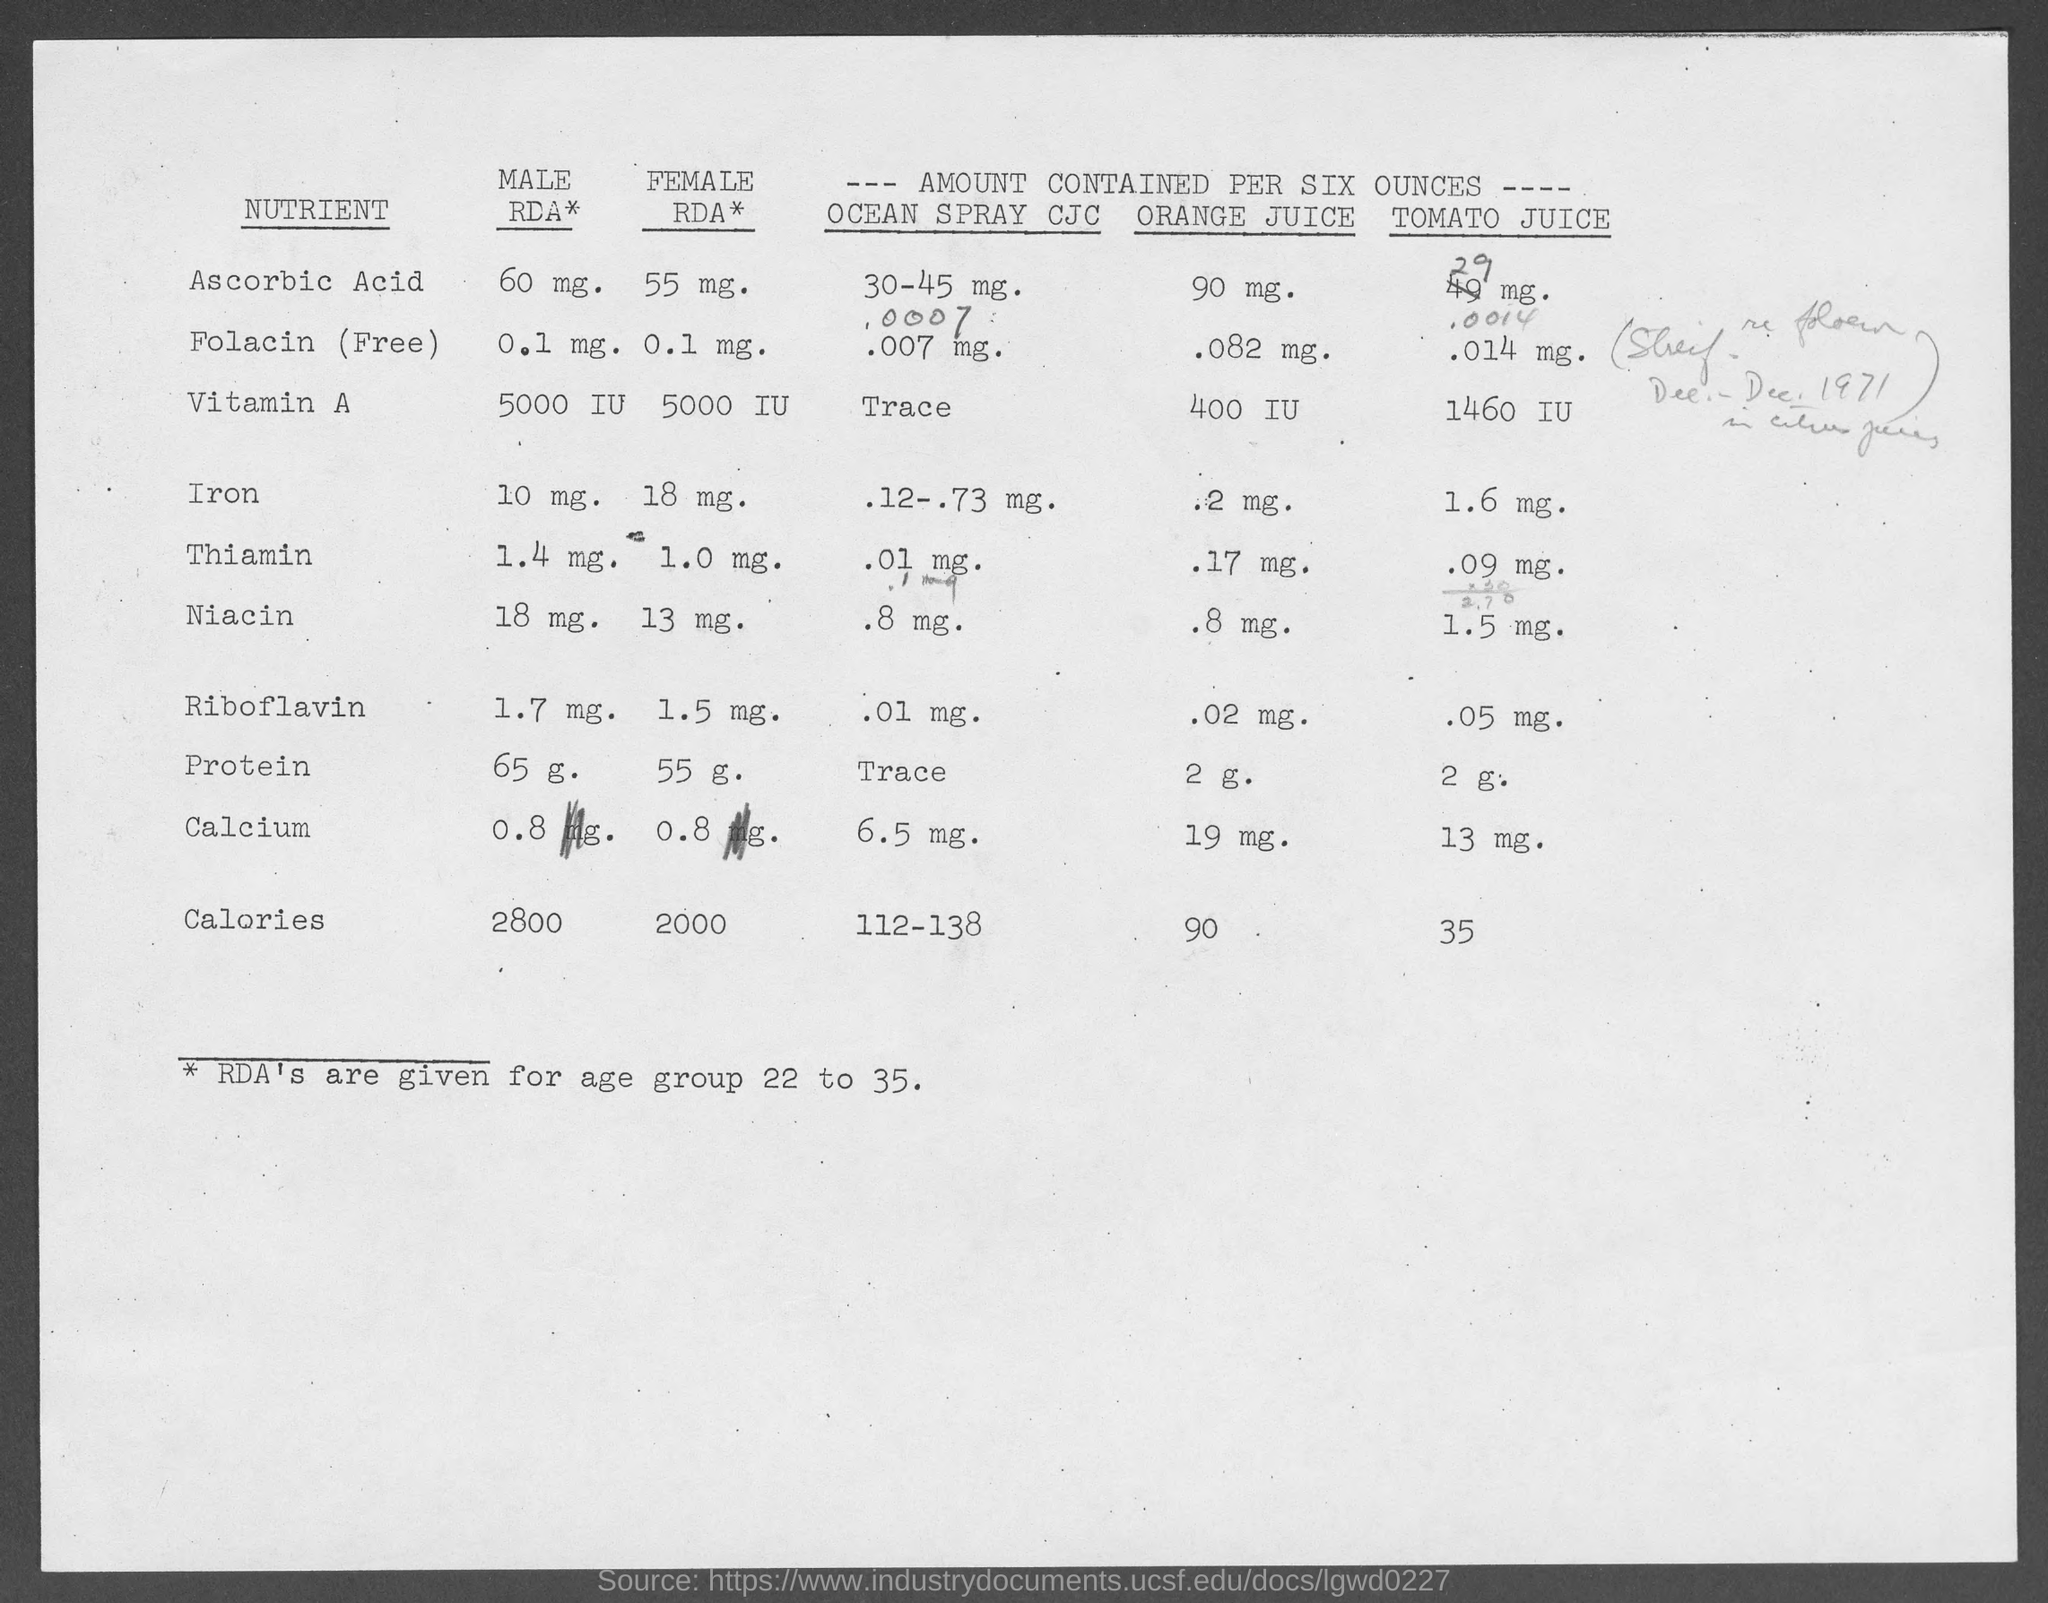What is the male rda* for ascorbic acid?
Provide a succinct answer. 60 mg. What is the male rda* for folacin (free)?
Give a very brief answer. 0.1. What is the male rda* for vitamin a?
Your response must be concise. 5000. What is the male rda* for iron ?
Provide a succinct answer. 10 mg. What is the male rda* for thiamin ?
Provide a succinct answer. 1.4 mg. What is the male rda* for niacin ?
Provide a succinct answer. 18. What is the male rda* for riboflavin ?
Your answer should be compact. 1.7. What is the male rda* for protein ?
Make the answer very short. 65 g. What is the male rda* for calcium ?
Your answer should be compact. 0.8. What is the male rda* for calories ?
Provide a short and direct response. 2800. 